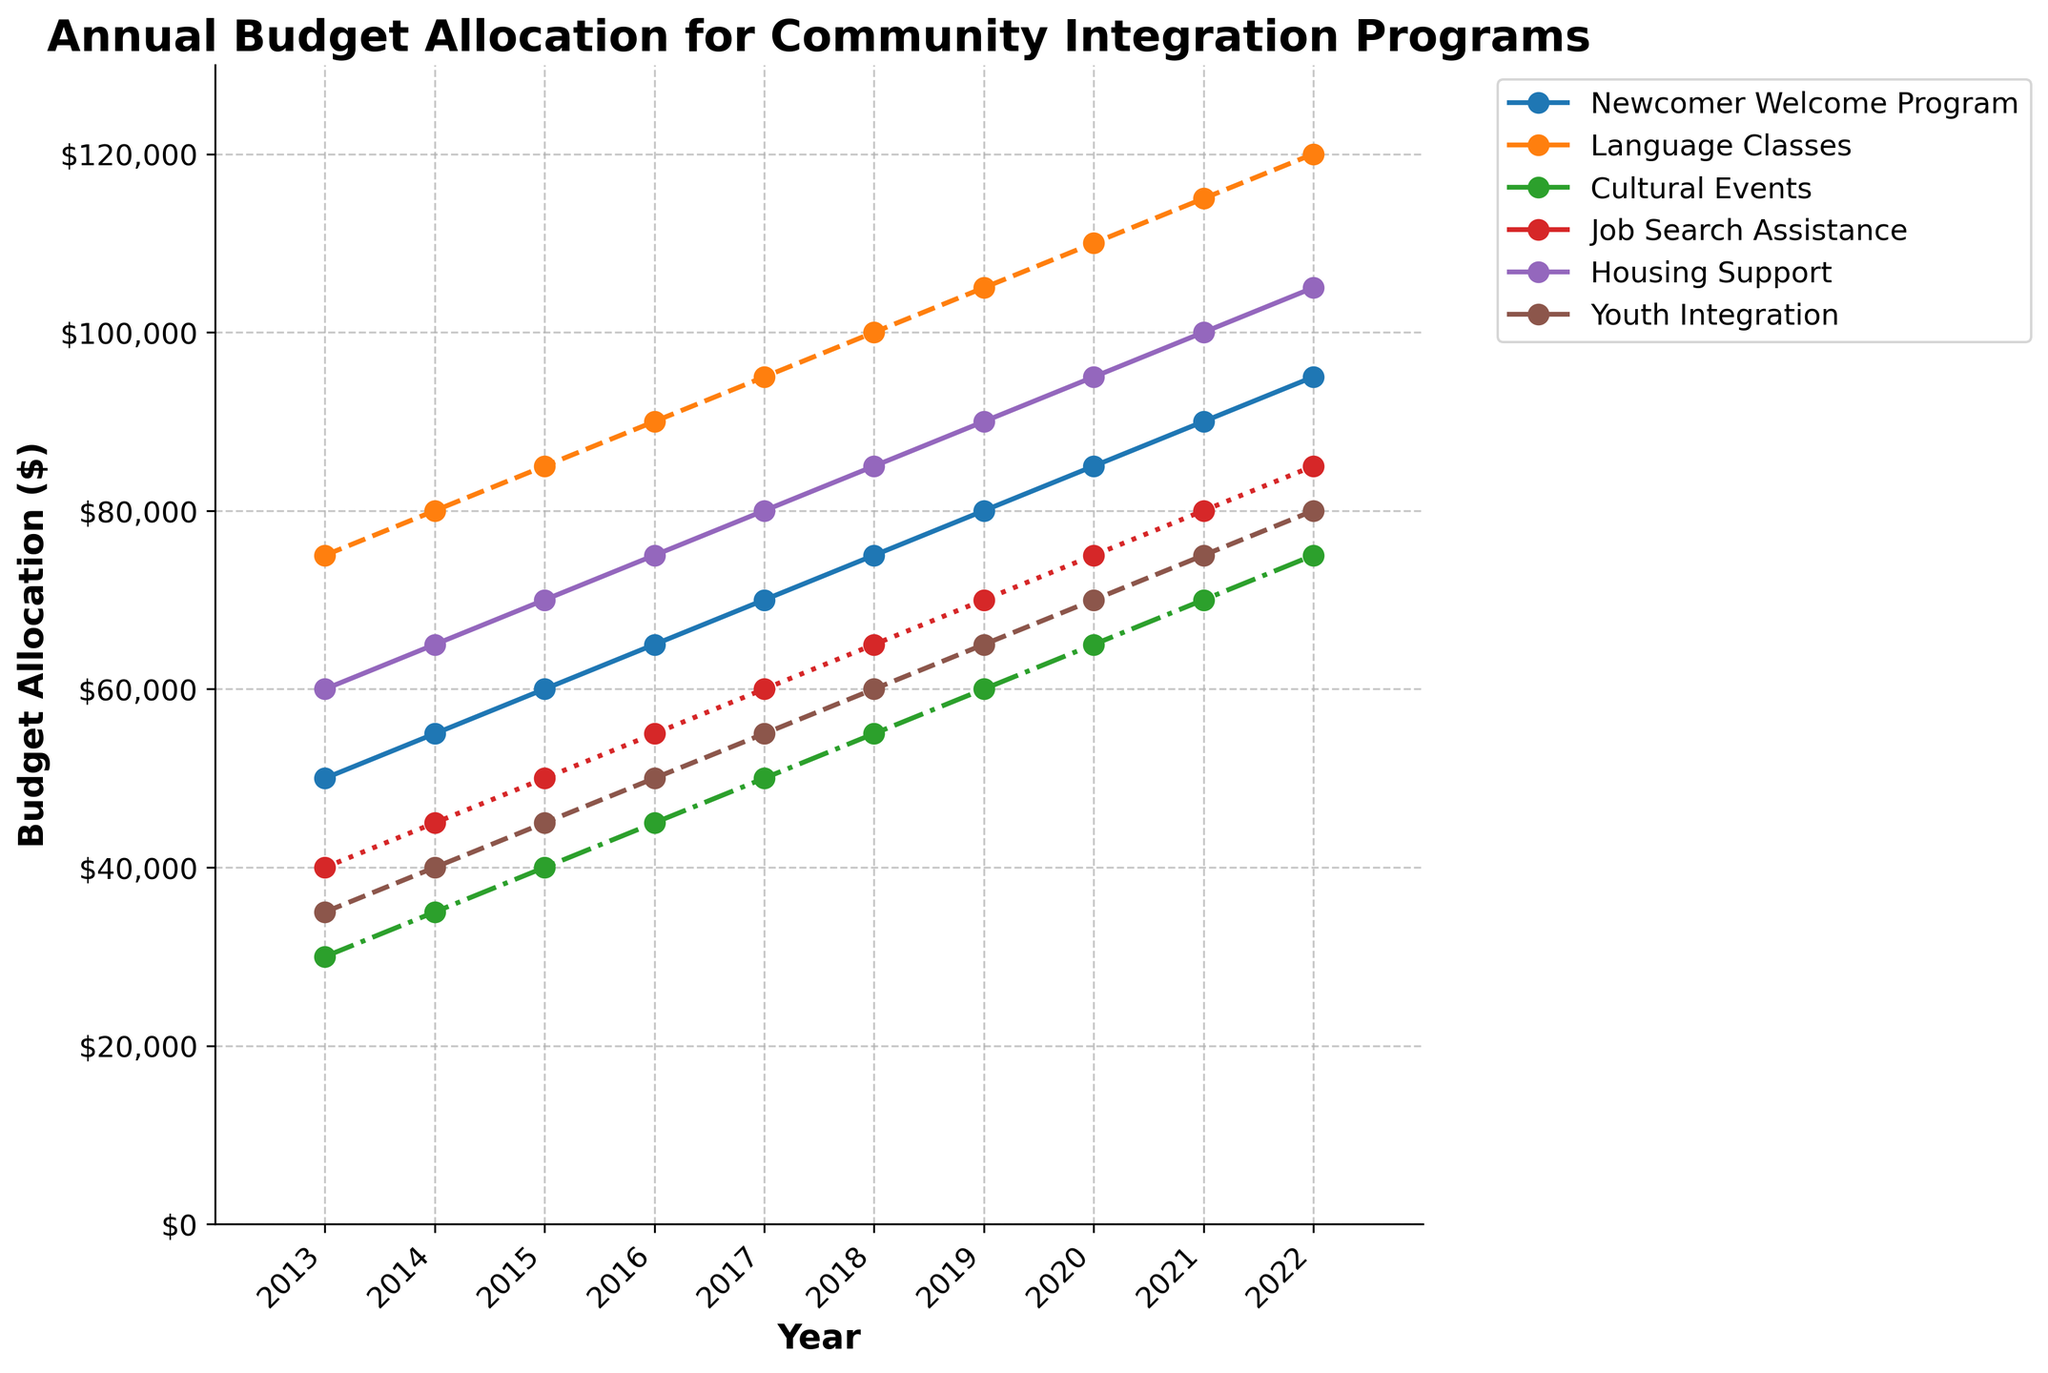How much more was allocated to the Housing Support initiative than to the Job Search Assistance initiative in 2019? Subtract the budget allocation for Job Search Assistance ($70,000) from that for Housing Support ($90,000) in 2019. The difference is $20,000.
Answer: $20,000 Which initiative received the highest budget allocation in 2022? Look at the values for each initiative in 2022 and identify the one with the highest value. Language Classes received $120,000, which is the highest.
Answer: Language Classes By how much did the budget for the Youth Integration initiative increase from 2015 to 2021? Subtract the value in 2015 ($45,000) from the value in 2021 ($75,000). The increase is $30,000.
Answer: $30,000 Between 2013 and 2016, which initiative saw the largest absolute increase in budget allocation? For each initiative, calculate the increase from 2013 to 2016 and compare them. The Newcomer Welcome Program increased from $50,000 to $65,000 (an increase of $15,000), Language Classes increased by $15,000, Cultural Events increased by $15,000, Job Search Assistance by $15,000, Housing Support by $15,000, and Youth Integration by $15,000. All initiatives saw the same largest increase of $15,000.
Answer: All initiatives What is the total budget allocated to the Newcomer Welcome Program over the entire 10-year period? Sum the annual allocations for the Newcomer Welcome Program from 2013 to 2022. The total is $50,000 + $55,000 + $60,000 + $65,000 + $70,000 + $75,000 + $80,000 + $85,000 + $90,000 + $95,000 = $725,000.
Answer: $725,000 Which two initiatives had identical budget allocations in any given year, and in which year did this occur? Compare the budget allocations for all initiatives across all years and find those with identical values. In 2015, both Language Classes and Housing Support received $85,000.
Answer: Language Classes and Housing Support, 2015 What was the average annual budget allocation for the Cultural Events initiative over the last 10 years? Sum the annual allocations for Cultural Events from 2013 to 2022 and divide by 10. $(30,000 + 35,000 + 40,000 + 45,000 + 50,000 + 55,000 + 60,000 + 65,000 + 70,000 + 75,000) / 10 = $52,500.
Answer: $52,500 In which year did the budget for Job Search Assistance and Youth Integration initiatives diverge the most, and what was the difference? Calculate the yearly differences between these initiatives and identify the maximum value. In 2022, Job Search Assistance was $85,000 and Youth Integration was $80,000, so the largest difference was $5,000.
Answer: 2022, $5,000 Which initiative saw the most consistent annual increase in budget allocation over the years? Analyze the yearly budget increments for each initiative and identify the one with a consistent pattern. Language Classes saw an annual increase of $5,000 each year from 2013 to 2022.
Answer: Language Classes 